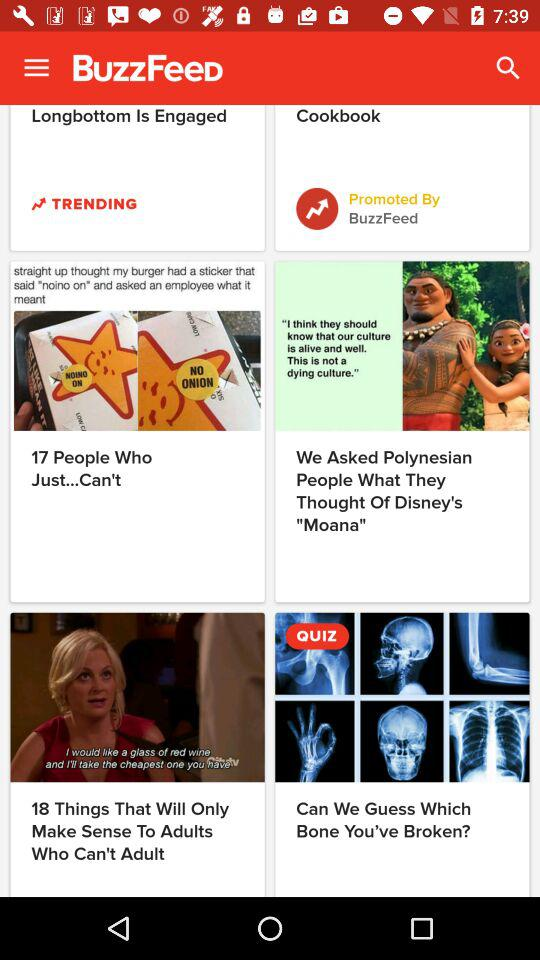What is the application name? The application name is "BuzzFeed". 